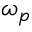Convert formula to latex. <formula><loc_0><loc_0><loc_500><loc_500>\omega _ { p }</formula> 